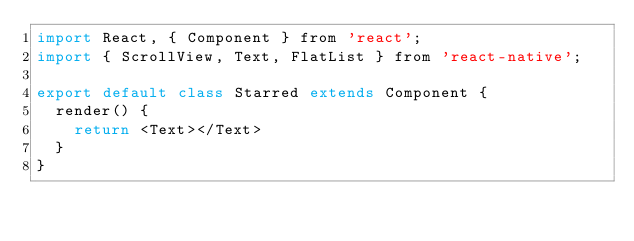Convert code to text. <code><loc_0><loc_0><loc_500><loc_500><_JavaScript_>import React, { Component } from 'react';
import { ScrollView, Text, FlatList } from 'react-native';

export default class Starred extends Component {
  render() {
    return <Text></Text>
  }
}
</code> 